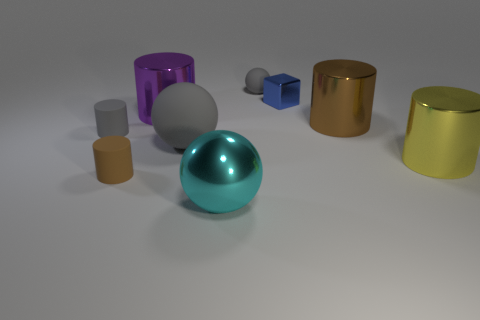Subtract all purple cylinders. How many cylinders are left? 4 Subtract all small brown cylinders. How many cylinders are left? 4 Subtract all blue cylinders. Subtract all brown balls. How many cylinders are left? 5 Subtract all cylinders. How many objects are left? 4 Add 5 tiny gray metal things. How many tiny gray metal things exist? 5 Subtract 1 blue blocks. How many objects are left? 8 Subtract all tiny brown rubber things. Subtract all small brown cylinders. How many objects are left? 7 Add 9 large purple cylinders. How many large purple cylinders are left? 10 